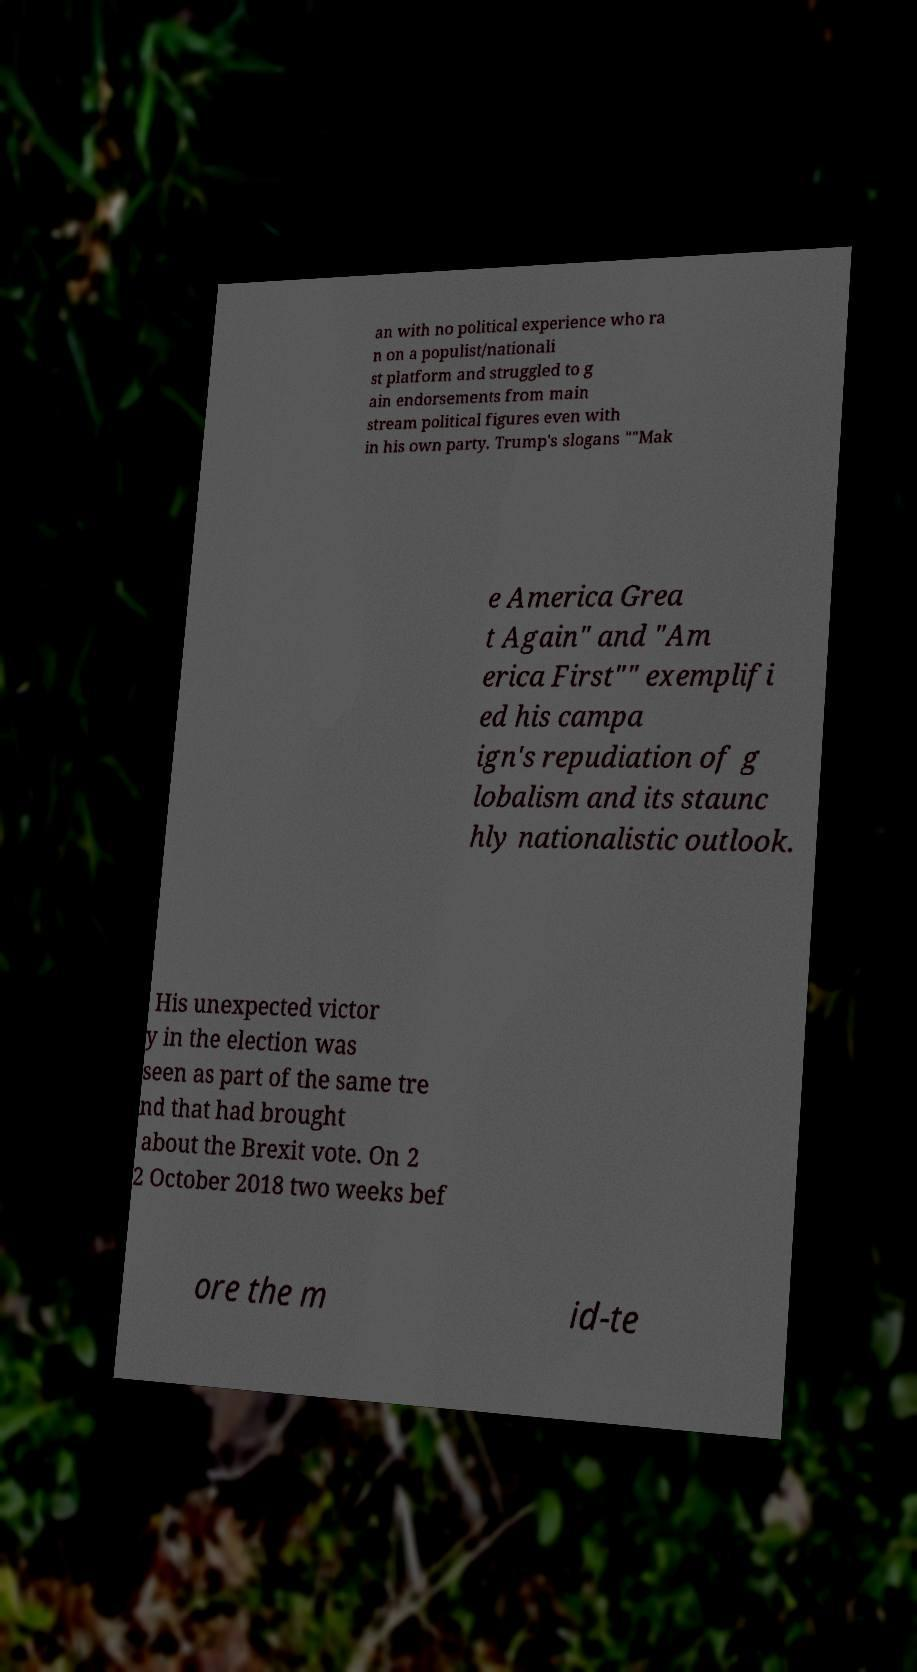What messages or text are displayed in this image? I need them in a readable, typed format. an with no political experience who ra n on a populist/nationali st platform and struggled to g ain endorsements from main stream political figures even with in his own party. Trump's slogans ""Mak e America Grea t Again" and "Am erica First"" exemplifi ed his campa ign's repudiation of g lobalism and its staunc hly nationalistic outlook. His unexpected victor y in the election was seen as part of the same tre nd that had brought about the Brexit vote. On 2 2 October 2018 two weeks bef ore the m id-te 